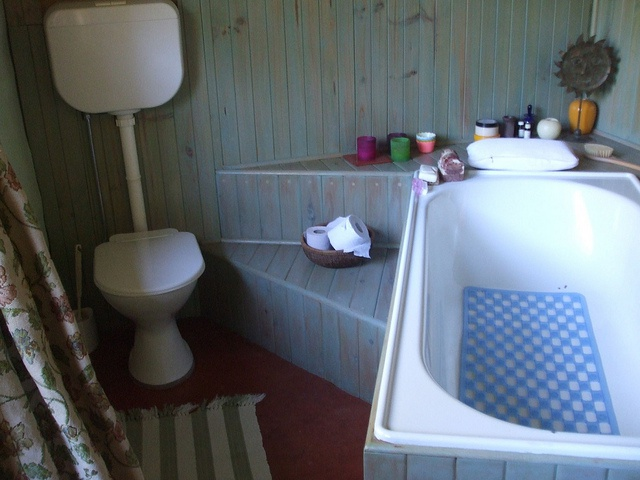Describe the objects in this image and their specific colors. I can see toilet in black and gray tones, bowl in black, lightblue, and gray tones, and vase in black, olive, maroon, and orange tones in this image. 